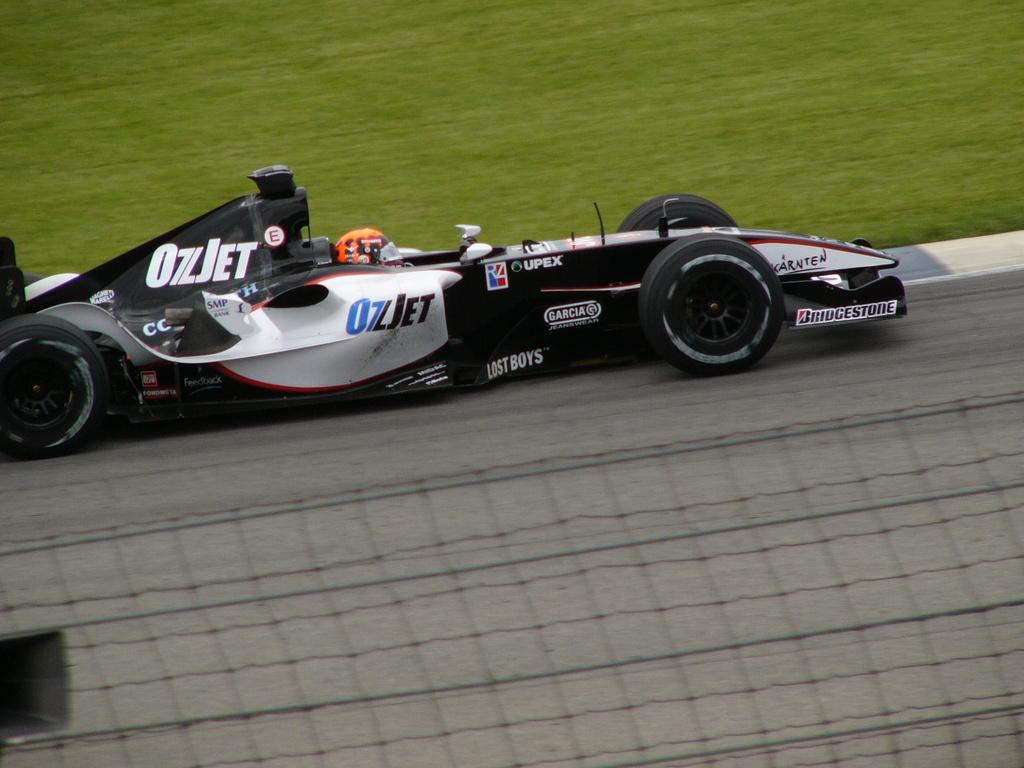What is the main subject of the image? There is a person riding a racing car in the image. Where is the racing car located? The racing car is on the road. What is at the bottom of the image? There is a fence at the bottom of the image. What type of vegetation can be seen behind the racing car? There is grass visible behind the racing car. What type of arch can be seen near the seashore in the image? There is no arch or seashore present in the image; it features a person riding a racing car on the road. What smell is associated with the racing car in the image? The image is visual, and smells cannot be determined from a visual representation. 